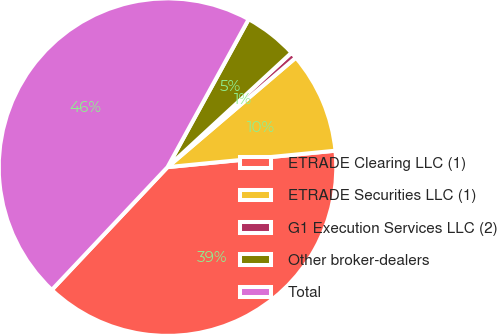Convert chart to OTSL. <chart><loc_0><loc_0><loc_500><loc_500><pie_chart><fcel>ETRADE Clearing LLC (1)<fcel>ETRADE Securities LLC (1)<fcel>G1 Execution Services LLC (2)<fcel>Other broker-dealers<fcel>Total<nl><fcel>38.58%<fcel>9.69%<fcel>0.62%<fcel>5.15%<fcel>45.96%<nl></chart> 